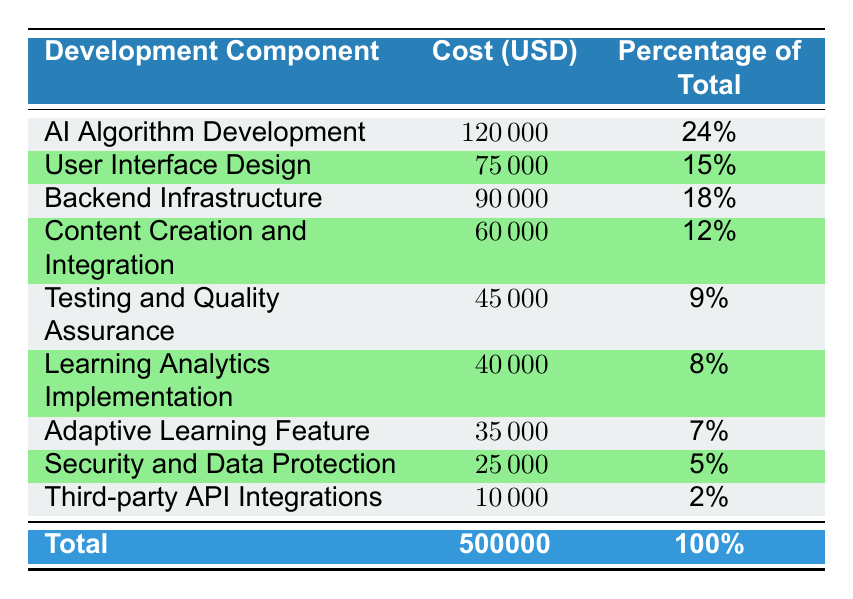What is the total cost of developing the AI-based e-learning platform? The total cost is provided in the table, listed as 500,000.
Answer: 500,000 What percentage of the total cost is allocated to user interface design? The percentage allocated to user interface design is explicitly stated in the table as 15%.
Answer: 15% Which component has the highest development cost? I need to look at the 'Cost (USD)' column and identify the component with the highest value, which is AI Algorithm Development with a cost of 120,000.
Answer: AI Algorithm Development What is the combined cost of testing and quality assurance and learning analytics implementation? I will find the costs for both components: Testing and Quality Assurance is 45,000 and Learning Analytics Implementation is 40,000. Adding these two together gives 45,000 + 40,000 = 85,000.
Answer: 85,000 Is the cost for third-party API integrations more than the cost for security and data protection? I will compare the costs for both: Third-party API Integrations is 10,000 and Security and Data Protection is 25,000. Since 10,000 is less than 25,000, the statement is false.
Answer: No What is the total percentage of costs associated with content creation and integration and the adaptive learning feature? I will look for the percentages for both components: Content Creation and Integration is 12% and Adaptive Learning Feature is 7%. Adding them gives 12% + 7% = 19%.
Answer: 19% Which two components together represent the lowest percentage of total costs? The lowest percentages in the table are for Third-party API Integrations at 2% and Security and Data Protection at 5%. Adding these gives 2% + 5% = 7%.
Answer: 7% What is the average cost of the top three most expensive development components? The top three most expensive components are AI Algorithm Development (120,000), Backend Infrastructure (90,000), and User Interface Design (75,000). Their total cost is 120,000 + 90,000 + 75,000 = 285,000. To find the average, I divide that by 3, giving 285,000 / 3 = 95,000.
Answer: 95,000 Is the cost for the AI algorithm development less than or equal to 30% of the total cost? First, I need to find 30% of the total cost, which is 30% of 500,000 = 150,000. Since the cost of AI Algorithm Development is 120,000, which is less than 150,000, the statement is true.
Answer: Yes 